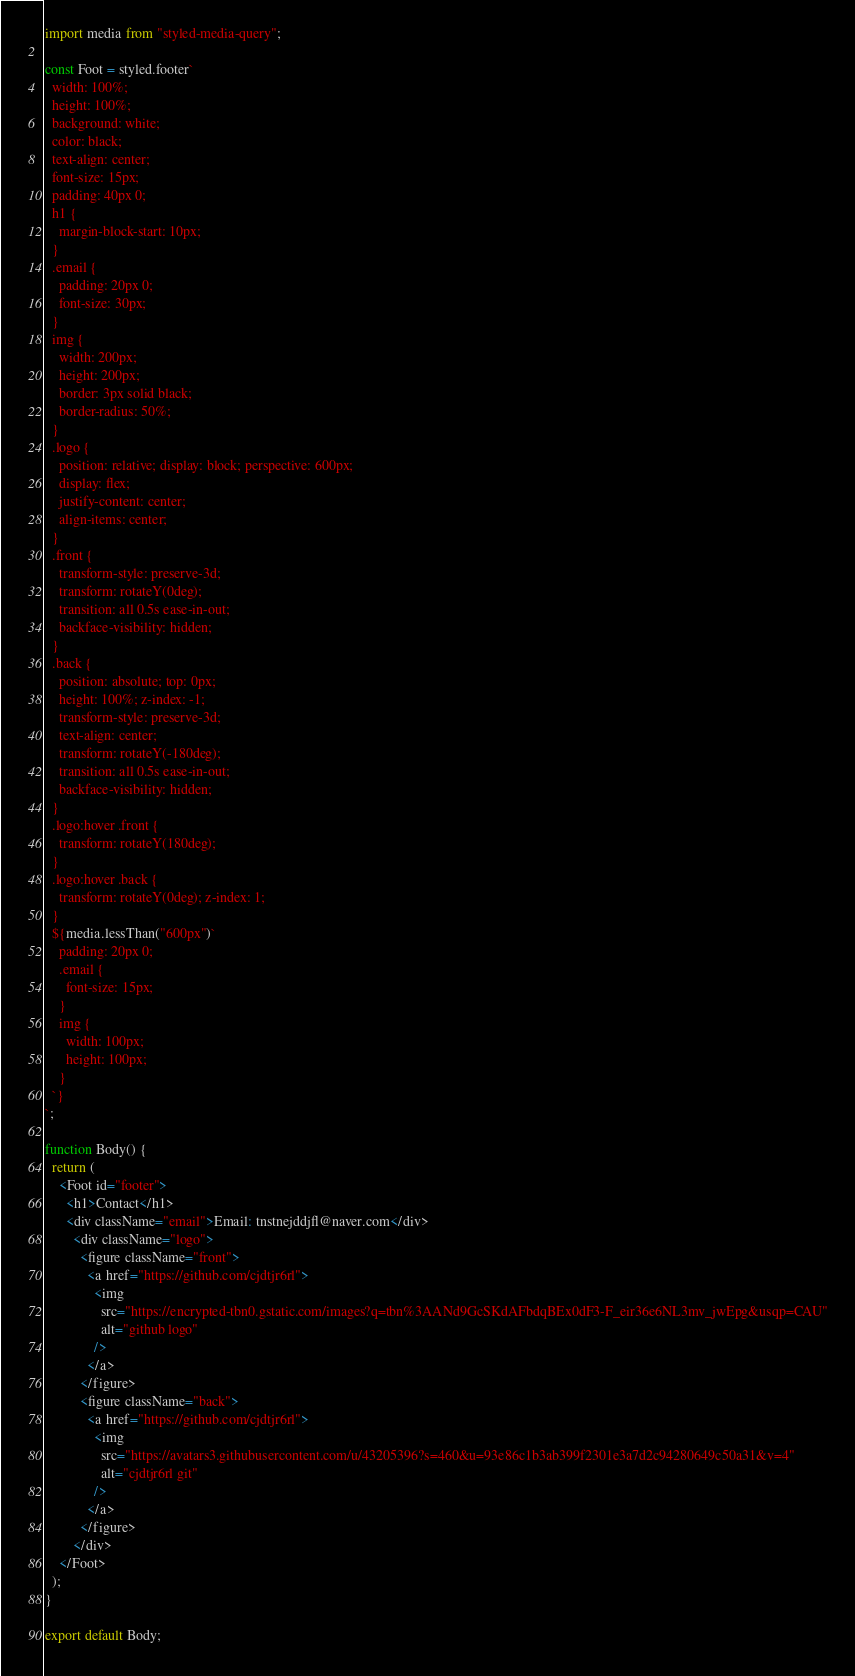<code> <loc_0><loc_0><loc_500><loc_500><_JavaScript_>import media from "styled-media-query";

const Foot = styled.footer`
  width: 100%;
  height: 100%;
  background: white;
  color: black;
  text-align: center;
  font-size: 15px;
  padding: 40px 0;
  h1 {
    margin-block-start: 10px;
  }
  .email {
    padding: 20px 0;
    font-size: 30px;
  }
  img {
    width: 200px;
    height: 200px;
    border: 3px solid black;
    border-radius: 50%;
  }
  .logo {
    position: relative; display: block; perspective: 600px;
    display: flex;
    justify-content: center;
    align-items: center;
  }
  .front {
    transform-style: preserve-3d;
    transform: rotateY(0deg);
    transition: all 0.5s ease-in-out;
    backface-visibility: hidden;
  }
  .back {
    position: absolute; top: 0px; 
    height: 100%; z-index: -1;
    transform-style: preserve-3d;
    text-align: center;
    transform: rotateY(-180deg);
    transition: all 0.5s ease-in-out;
    backface-visibility: hidden;
  }
  .logo:hover .front {
    transform: rotateY(180deg);
  }
  .logo:hover .back {
    transform: rotateY(0deg); z-index: 1;
  }
  ${media.lessThan("600px")`
    padding: 20px 0;
    .email {
      font-size: 15px;
    }
    img {
      width: 100px;
      height: 100px;
    }
  `}
`;

function Body() {
  return (
    <Foot id="footer">
      <h1>Contact</h1>
      <div className="email">Email: tnstnejddjfl@naver.com</div>
        <div className="logo">
          <figure className="front">
            <a href="https://github.com/cjdtjr6rl">
              <img
                src="https://encrypted-tbn0.gstatic.com/images?q=tbn%3AANd9GcSKdAFbdqBEx0dF3-F_eir36e6NL3mv_jwEpg&usqp=CAU"
                alt="github logo"
              />
            </a>
          </figure>
          <figure className="back">
            <a href="https://github.com/cjdtjr6rl">
              <img
                src="https://avatars3.githubusercontent.com/u/43205396?s=460&u=93e86c1b3ab399f2301e3a7d2c94280649c50a31&v=4"
                alt="cjdtjr6rl git"
              />
            </a>
          </figure>
        </div>
    </Foot>
  );
}

export default Body;
</code> 